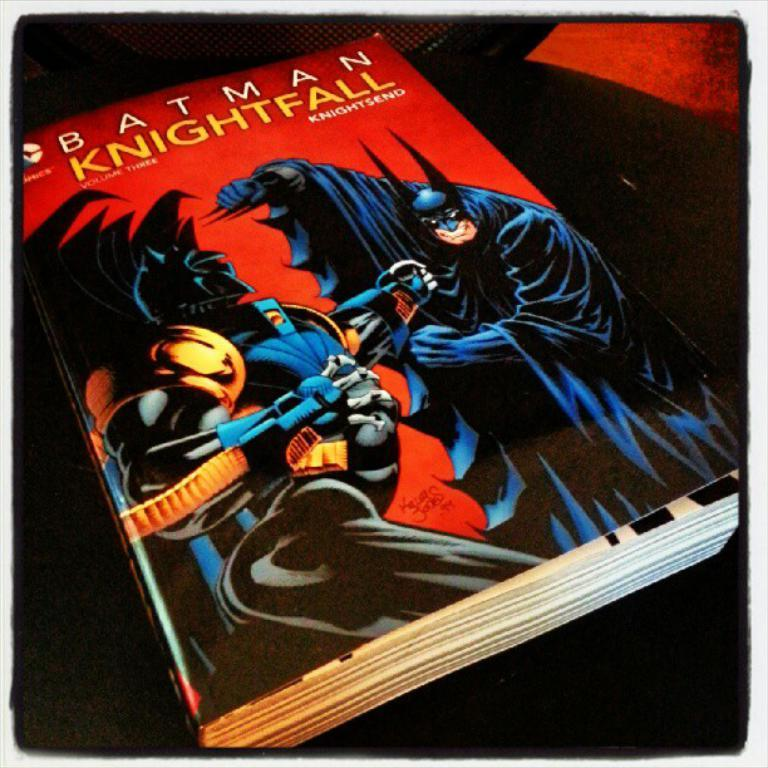<image>
Share a concise interpretation of the image provided. a book that is called Batman with a villain on it 